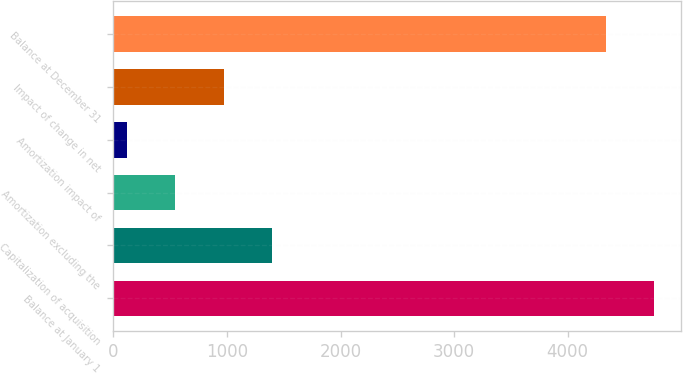Convert chart. <chart><loc_0><loc_0><loc_500><loc_500><bar_chart><fcel>Balance at January 1<fcel>Capitalization of acquisition<fcel>Amortization excluding the<fcel>Amortization impact of<fcel>Impact of change in net<fcel>Balance at December 31<nl><fcel>4760.4<fcel>1398.2<fcel>545.4<fcel>119<fcel>971.8<fcel>4334<nl></chart> 